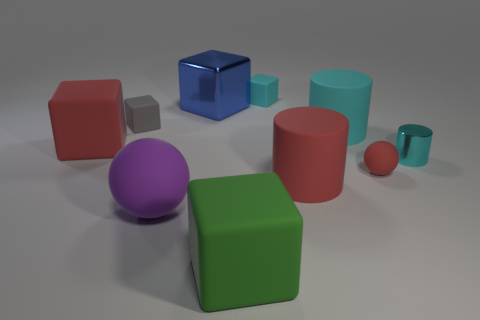How many things are either big rubber things in front of the large red rubber cube or purple rubber balls?
Offer a very short reply. 3. How big is the blue cube?
Ensure brevity in your answer.  Large. What material is the small cyan object that is in front of the rubber block that is to the right of the large green thing?
Ensure brevity in your answer.  Metal. Does the cylinder behind the red matte block have the same size as the purple rubber object?
Offer a terse response. Yes. Are there any big rubber cubes that have the same color as the tiny sphere?
Provide a short and direct response. Yes. How many things are either large matte things that are right of the gray block or small rubber blocks that are on the right side of the big green object?
Your answer should be compact. 5. There is a block that is the same color as the small rubber ball; what is its material?
Provide a succinct answer. Rubber. Are there fewer tiny cyan cylinders that are behind the small cyan metal cylinder than large red matte objects that are on the right side of the tiny cyan cube?
Provide a short and direct response. Yes. Is the big red block made of the same material as the big blue thing?
Ensure brevity in your answer.  No. What is the size of the matte block that is both behind the red block and to the left of the small cyan cube?
Ensure brevity in your answer.  Small. 